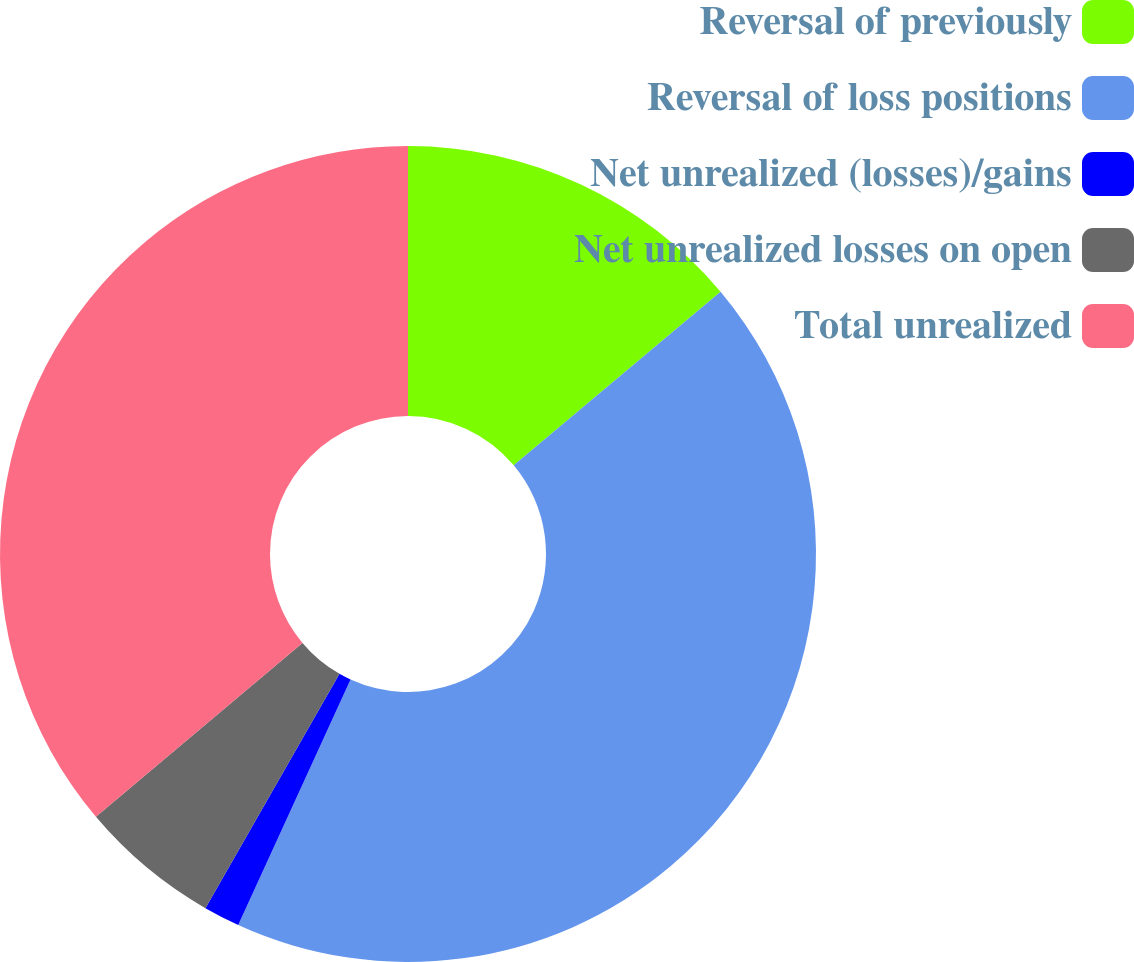<chart> <loc_0><loc_0><loc_500><loc_500><pie_chart><fcel>Reversal of previously<fcel>Reversal of loss positions<fcel>Net unrealized (losses)/gains<fcel>Net unrealized losses on open<fcel>Total unrealized<nl><fcel>13.89%<fcel>42.94%<fcel>1.44%<fcel>5.59%<fcel>36.14%<nl></chart> 